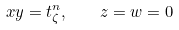Convert formula to latex. <formula><loc_0><loc_0><loc_500><loc_500>x y = t _ { \zeta } ^ { n } , \quad z = w = 0</formula> 